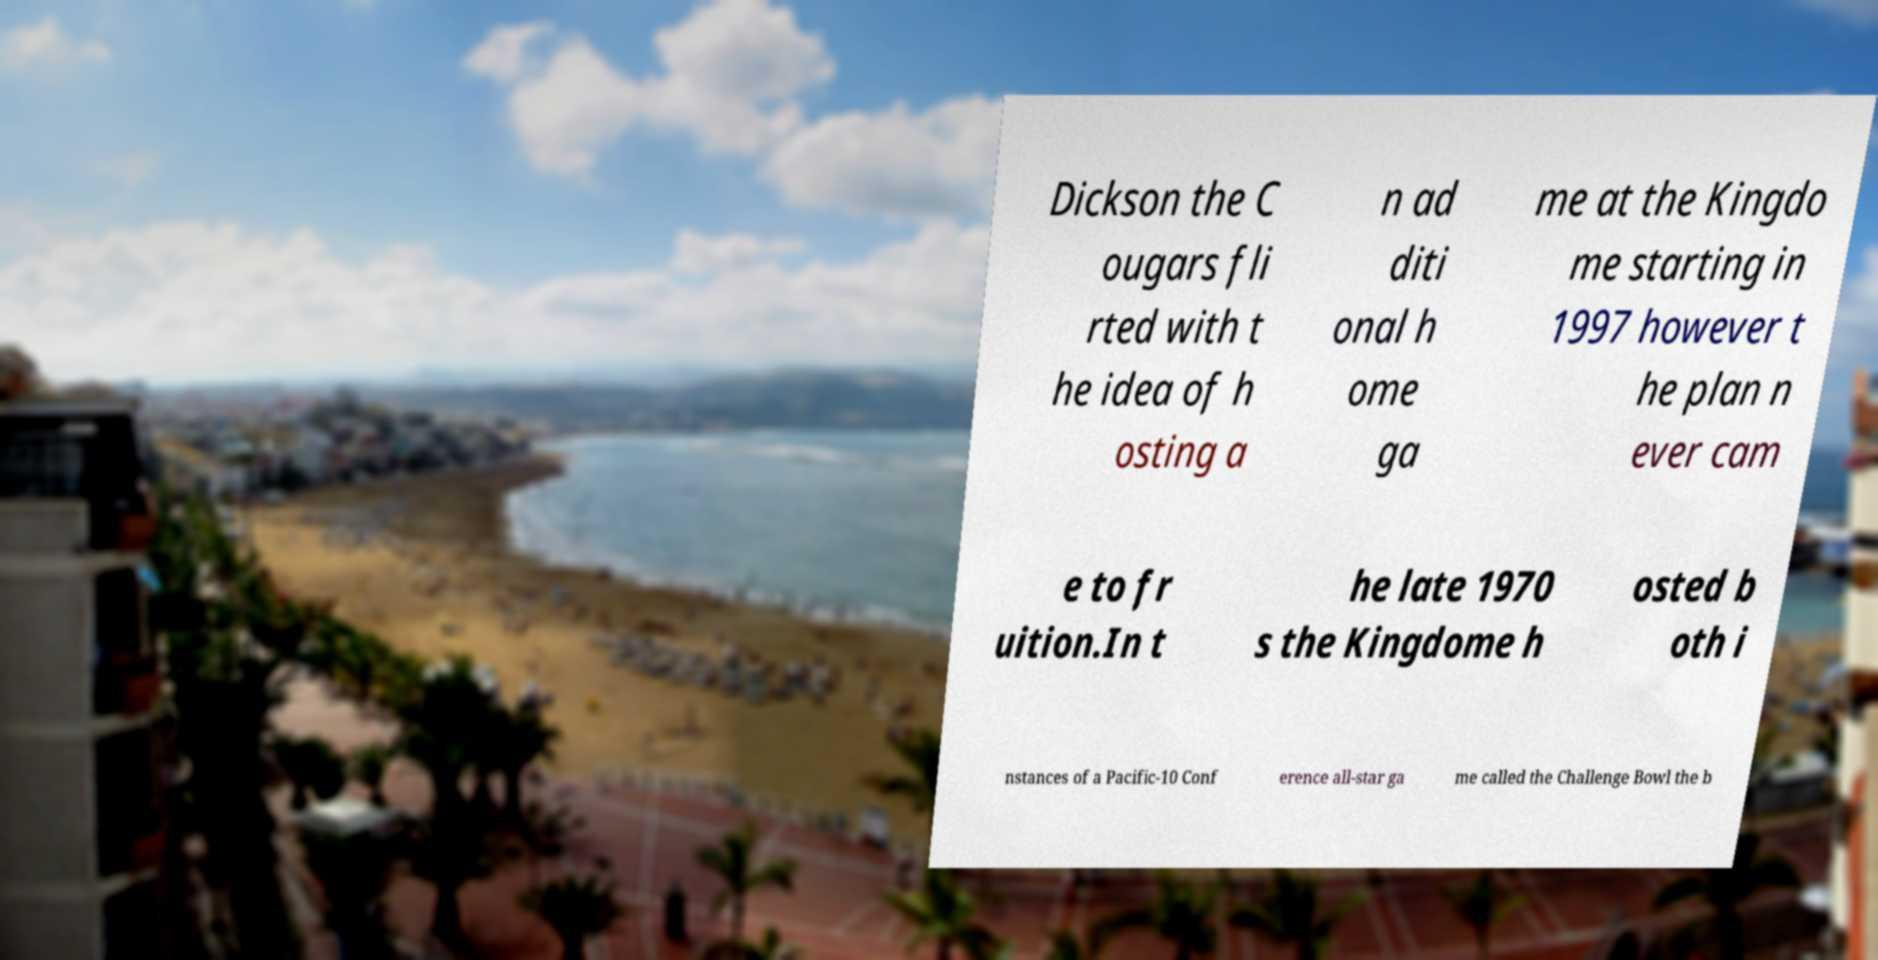There's text embedded in this image that I need extracted. Can you transcribe it verbatim? Dickson the C ougars fli rted with t he idea of h osting a n ad diti onal h ome ga me at the Kingdo me starting in 1997 however t he plan n ever cam e to fr uition.In t he late 1970 s the Kingdome h osted b oth i nstances of a Pacific-10 Conf erence all-star ga me called the Challenge Bowl the b 